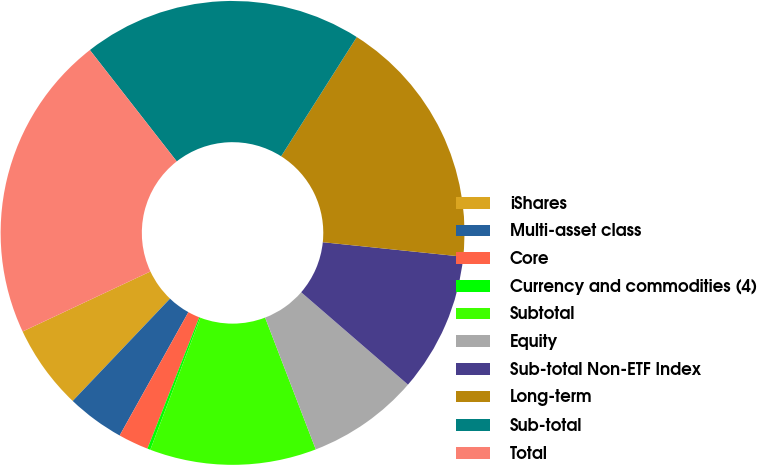Convert chart to OTSL. <chart><loc_0><loc_0><loc_500><loc_500><pie_chart><fcel>iShares<fcel>Multi-asset class<fcel>Core<fcel>Currency and commodities (4)<fcel>Subtotal<fcel>Equity<fcel>Sub-total Non-ETF Index<fcel>Long-term<fcel>Sub-total<fcel>Total<nl><fcel>5.91%<fcel>4.01%<fcel>2.11%<fcel>0.21%<fcel>11.61%<fcel>7.81%<fcel>9.71%<fcel>17.64%<fcel>19.54%<fcel>21.44%<nl></chart> 